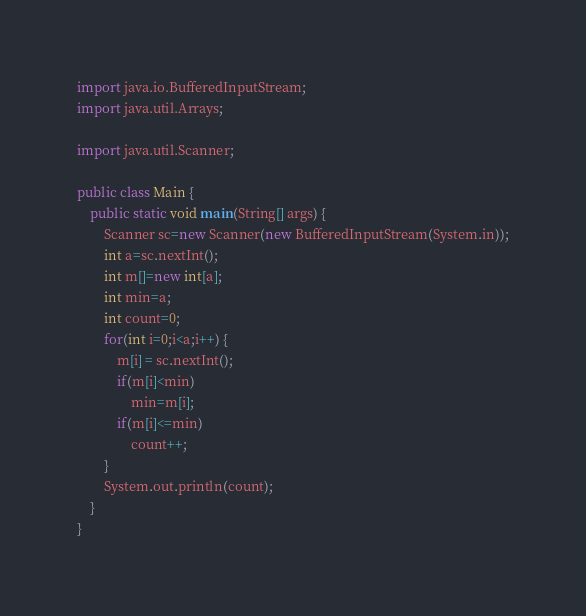<code> <loc_0><loc_0><loc_500><loc_500><_Java_>import java.io.BufferedInputStream;
import java.util.Arrays;

import java.util.Scanner;

public class Main {
    public static void main(String[] args) {
        Scanner sc=new Scanner(new BufferedInputStream(System.in));
        int a=sc.nextInt();
        int m[]=new int[a];
        int min=a;
        int count=0;
        for(int i=0;i<a;i++) {
            m[i] = sc.nextInt();
            if(m[i]<min)
                min=m[i];
            if(m[i]<=min)
                count++;
        }
        System.out.println(count);
    }
}
</code> 